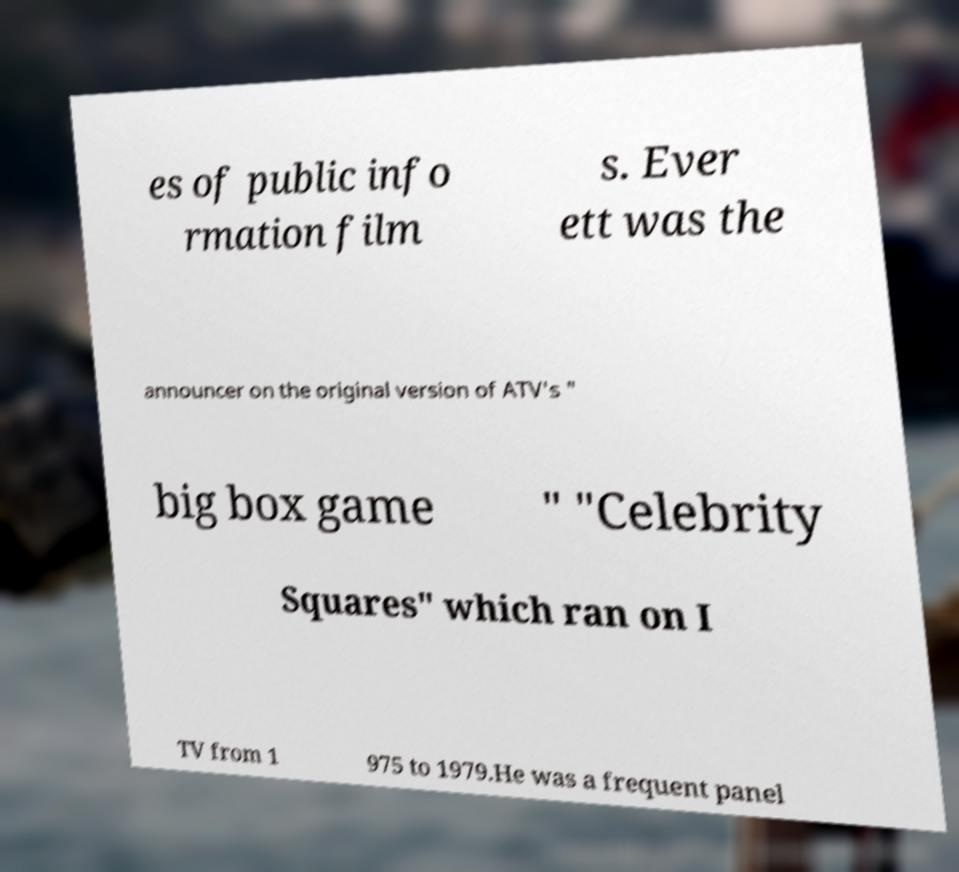What messages or text are displayed in this image? I need them in a readable, typed format. es of public info rmation film s. Ever ett was the announcer on the original version of ATV's " big box game " "Celebrity Squares" which ran on I TV from 1 975 to 1979.He was a frequent panel 